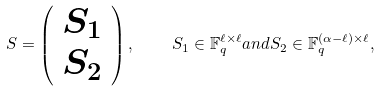<formula> <loc_0><loc_0><loc_500><loc_500>S = \left ( \begin{array} { c } S _ { 1 } \\ S _ { 2 } \end{array} \right ) , \quad S _ { 1 } \in \mathbb { F } _ { q } ^ { \ell \times \ell } a n d S _ { 2 } \in \mathbb { F } _ { q } ^ { ( \alpha - \ell ) \times \ell } ,</formula> 